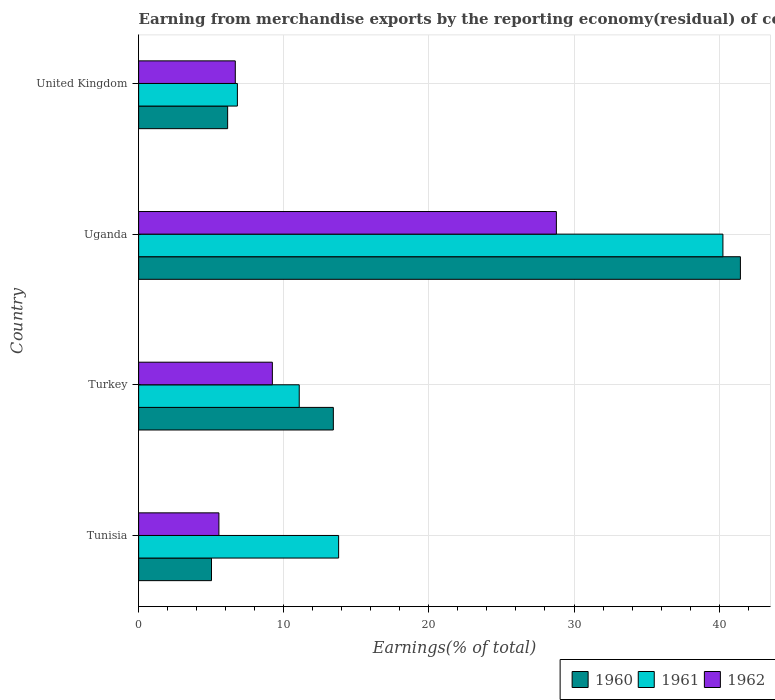How many groups of bars are there?
Your response must be concise. 4. What is the label of the 1st group of bars from the top?
Give a very brief answer. United Kingdom. In how many cases, is the number of bars for a given country not equal to the number of legend labels?
Provide a succinct answer. 0. What is the percentage of amount earned from merchandise exports in 1960 in Turkey?
Provide a succinct answer. 13.42. Across all countries, what is the maximum percentage of amount earned from merchandise exports in 1960?
Your response must be concise. 41.47. Across all countries, what is the minimum percentage of amount earned from merchandise exports in 1962?
Provide a succinct answer. 5.53. In which country was the percentage of amount earned from merchandise exports in 1960 maximum?
Your answer should be very brief. Uganda. In which country was the percentage of amount earned from merchandise exports in 1960 minimum?
Your answer should be compact. Tunisia. What is the total percentage of amount earned from merchandise exports in 1960 in the graph?
Ensure brevity in your answer.  66.04. What is the difference between the percentage of amount earned from merchandise exports in 1960 in Uganda and that in United Kingdom?
Offer a very short reply. 35.33. What is the difference between the percentage of amount earned from merchandise exports in 1961 in Uganda and the percentage of amount earned from merchandise exports in 1960 in United Kingdom?
Provide a succinct answer. 34.13. What is the average percentage of amount earned from merchandise exports in 1960 per country?
Keep it short and to the point. 16.51. What is the difference between the percentage of amount earned from merchandise exports in 1960 and percentage of amount earned from merchandise exports in 1962 in Turkey?
Offer a terse response. 4.2. In how many countries, is the percentage of amount earned from merchandise exports in 1961 greater than 6 %?
Your answer should be very brief. 4. What is the ratio of the percentage of amount earned from merchandise exports in 1961 in Tunisia to that in Uganda?
Your response must be concise. 0.34. What is the difference between the highest and the second highest percentage of amount earned from merchandise exports in 1961?
Offer a terse response. 26.48. What is the difference between the highest and the lowest percentage of amount earned from merchandise exports in 1962?
Keep it short and to the point. 23.25. In how many countries, is the percentage of amount earned from merchandise exports in 1962 greater than the average percentage of amount earned from merchandise exports in 1962 taken over all countries?
Provide a short and direct response. 1. What does the 3rd bar from the top in Turkey represents?
Offer a terse response. 1960. Is it the case that in every country, the sum of the percentage of amount earned from merchandise exports in 1962 and percentage of amount earned from merchandise exports in 1960 is greater than the percentage of amount earned from merchandise exports in 1961?
Your response must be concise. No. How many bars are there?
Ensure brevity in your answer.  12. How many countries are there in the graph?
Make the answer very short. 4. What is the difference between two consecutive major ticks on the X-axis?
Offer a very short reply. 10. Does the graph contain grids?
Provide a succinct answer. Yes. How are the legend labels stacked?
Offer a very short reply. Horizontal. What is the title of the graph?
Provide a short and direct response. Earning from merchandise exports by the reporting economy(residual) of countries. Does "1967" appear as one of the legend labels in the graph?
Provide a succinct answer. No. What is the label or title of the X-axis?
Your answer should be compact. Earnings(% of total). What is the Earnings(% of total) in 1960 in Tunisia?
Your response must be concise. 5.02. What is the Earnings(% of total) of 1961 in Tunisia?
Provide a short and direct response. 13.78. What is the Earnings(% of total) in 1962 in Tunisia?
Offer a very short reply. 5.53. What is the Earnings(% of total) in 1960 in Turkey?
Keep it short and to the point. 13.42. What is the Earnings(% of total) of 1961 in Turkey?
Provide a succinct answer. 11.07. What is the Earnings(% of total) of 1962 in Turkey?
Keep it short and to the point. 9.22. What is the Earnings(% of total) in 1960 in Uganda?
Make the answer very short. 41.47. What is the Earnings(% of total) of 1961 in Uganda?
Provide a short and direct response. 40.26. What is the Earnings(% of total) of 1962 in Uganda?
Your response must be concise. 28.79. What is the Earnings(% of total) in 1960 in United Kingdom?
Give a very brief answer. 6.13. What is the Earnings(% of total) in 1961 in United Kingdom?
Your answer should be very brief. 6.81. What is the Earnings(% of total) of 1962 in United Kingdom?
Provide a succinct answer. 6.66. Across all countries, what is the maximum Earnings(% of total) of 1960?
Your answer should be compact. 41.47. Across all countries, what is the maximum Earnings(% of total) in 1961?
Give a very brief answer. 40.26. Across all countries, what is the maximum Earnings(% of total) in 1962?
Provide a short and direct response. 28.79. Across all countries, what is the minimum Earnings(% of total) in 1960?
Keep it short and to the point. 5.02. Across all countries, what is the minimum Earnings(% of total) in 1961?
Make the answer very short. 6.81. Across all countries, what is the minimum Earnings(% of total) of 1962?
Your answer should be compact. 5.53. What is the total Earnings(% of total) of 1960 in the graph?
Offer a very short reply. 66.04. What is the total Earnings(% of total) of 1961 in the graph?
Make the answer very short. 71.91. What is the total Earnings(% of total) of 1962 in the graph?
Your answer should be very brief. 50.19. What is the difference between the Earnings(% of total) of 1960 in Tunisia and that in Turkey?
Your response must be concise. -8.4. What is the difference between the Earnings(% of total) in 1961 in Tunisia and that in Turkey?
Keep it short and to the point. 2.71. What is the difference between the Earnings(% of total) in 1962 in Tunisia and that in Turkey?
Your response must be concise. -3.68. What is the difference between the Earnings(% of total) in 1960 in Tunisia and that in Uganda?
Offer a terse response. -36.44. What is the difference between the Earnings(% of total) in 1961 in Tunisia and that in Uganda?
Ensure brevity in your answer.  -26.48. What is the difference between the Earnings(% of total) in 1962 in Tunisia and that in Uganda?
Ensure brevity in your answer.  -23.25. What is the difference between the Earnings(% of total) in 1960 in Tunisia and that in United Kingdom?
Offer a terse response. -1.11. What is the difference between the Earnings(% of total) of 1961 in Tunisia and that in United Kingdom?
Provide a succinct answer. 6.98. What is the difference between the Earnings(% of total) of 1962 in Tunisia and that in United Kingdom?
Offer a terse response. -1.13. What is the difference between the Earnings(% of total) in 1960 in Turkey and that in Uganda?
Provide a succinct answer. -28.05. What is the difference between the Earnings(% of total) of 1961 in Turkey and that in Uganda?
Make the answer very short. -29.19. What is the difference between the Earnings(% of total) in 1962 in Turkey and that in Uganda?
Ensure brevity in your answer.  -19.57. What is the difference between the Earnings(% of total) in 1960 in Turkey and that in United Kingdom?
Ensure brevity in your answer.  7.28. What is the difference between the Earnings(% of total) in 1961 in Turkey and that in United Kingdom?
Provide a short and direct response. 4.26. What is the difference between the Earnings(% of total) in 1962 in Turkey and that in United Kingdom?
Offer a very short reply. 2.55. What is the difference between the Earnings(% of total) in 1960 in Uganda and that in United Kingdom?
Your answer should be compact. 35.33. What is the difference between the Earnings(% of total) of 1961 in Uganda and that in United Kingdom?
Make the answer very short. 33.46. What is the difference between the Earnings(% of total) of 1962 in Uganda and that in United Kingdom?
Give a very brief answer. 22.12. What is the difference between the Earnings(% of total) in 1960 in Tunisia and the Earnings(% of total) in 1961 in Turkey?
Your answer should be compact. -6.05. What is the difference between the Earnings(% of total) of 1960 in Tunisia and the Earnings(% of total) of 1962 in Turkey?
Offer a terse response. -4.19. What is the difference between the Earnings(% of total) of 1961 in Tunisia and the Earnings(% of total) of 1962 in Turkey?
Make the answer very short. 4.57. What is the difference between the Earnings(% of total) in 1960 in Tunisia and the Earnings(% of total) in 1961 in Uganda?
Ensure brevity in your answer.  -35.24. What is the difference between the Earnings(% of total) in 1960 in Tunisia and the Earnings(% of total) in 1962 in Uganda?
Ensure brevity in your answer.  -23.76. What is the difference between the Earnings(% of total) in 1961 in Tunisia and the Earnings(% of total) in 1962 in Uganda?
Offer a terse response. -15. What is the difference between the Earnings(% of total) in 1960 in Tunisia and the Earnings(% of total) in 1961 in United Kingdom?
Your response must be concise. -1.78. What is the difference between the Earnings(% of total) of 1960 in Tunisia and the Earnings(% of total) of 1962 in United Kingdom?
Provide a succinct answer. -1.64. What is the difference between the Earnings(% of total) of 1961 in Tunisia and the Earnings(% of total) of 1962 in United Kingdom?
Provide a short and direct response. 7.12. What is the difference between the Earnings(% of total) of 1960 in Turkey and the Earnings(% of total) of 1961 in Uganda?
Ensure brevity in your answer.  -26.84. What is the difference between the Earnings(% of total) in 1960 in Turkey and the Earnings(% of total) in 1962 in Uganda?
Ensure brevity in your answer.  -15.37. What is the difference between the Earnings(% of total) in 1961 in Turkey and the Earnings(% of total) in 1962 in Uganda?
Make the answer very short. -17.72. What is the difference between the Earnings(% of total) in 1960 in Turkey and the Earnings(% of total) in 1961 in United Kingdom?
Keep it short and to the point. 6.61. What is the difference between the Earnings(% of total) of 1960 in Turkey and the Earnings(% of total) of 1962 in United Kingdom?
Offer a very short reply. 6.76. What is the difference between the Earnings(% of total) of 1961 in Turkey and the Earnings(% of total) of 1962 in United Kingdom?
Give a very brief answer. 4.41. What is the difference between the Earnings(% of total) in 1960 in Uganda and the Earnings(% of total) in 1961 in United Kingdom?
Your answer should be very brief. 34.66. What is the difference between the Earnings(% of total) of 1960 in Uganda and the Earnings(% of total) of 1962 in United Kingdom?
Your response must be concise. 34.8. What is the difference between the Earnings(% of total) in 1961 in Uganda and the Earnings(% of total) in 1962 in United Kingdom?
Offer a terse response. 33.6. What is the average Earnings(% of total) in 1960 per country?
Your answer should be very brief. 16.51. What is the average Earnings(% of total) of 1961 per country?
Your answer should be compact. 17.98. What is the average Earnings(% of total) in 1962 per country?
Provide a short and direct response. 12.55. What is the difference between the Earnings(% of total) in 1960 and Earnings(% of total) in 1961 in Tunisia?
Provide a short and direct response. -8.76. What is the difference between the Earnings(% of total) in 1960 and Earnings(% of total) in 1962 in Tunisia?
Offer a very short reply. -0.51. What is the difference between the Earnings(% of total) in 1961 and Earnings(% of total) in 1962 in Tunisia?
Provide a short and direct response. 8.25. What is the difference between the Earnings(% of total) in 1960 and Earnings(% of total) in 1961 in Turkey?
Provide a succinct answer. 2.35. What is the difference between the Earnings(% of total) in 1960 and Earnings(% of total) in 1962 in Turkey?
Provide a short and direct response. 4.2. What is the difference between the Earnings(% of total) of 1961 and Earnings(% of total) of 1962 in Turkey?
Offer a very short reply. 1.85. What is the difference between the Earnings(% of total) of 1960 and Earnings(% of total) of 1961 in Uganda?
Your response must be concise. 1.2. What is the difference between the Earnings(% of total) of 1960 and Earnings(% of total) of 1962 in Uganda?
Your answer should be compact. 12.68. What is the difference between the Earnings(% of total) in 1961 and Earnings(% of total) in 1962 in Uganda?
Provide a succinct answer. 11.48. What is the difference between the Earnings(% of total) in 1960 and Earnings(% of total) in 1961 in United Kingdom?
Make the answer very short. -0.67. What is the difference between the Earnings(% of total) of 1960 and Earnings(% of total) of 1962 in United Kingdom?
Make the answer very short. -0.53. What is the difference between the Earnings(% of total) of 1961 and Earnings(% of total) of 1962 in United Kingdom?
Provide a short and direct response. 0.14. What is the ratio of the Earnings(% of total) of 1960 in Tunisia to that in Turkey?
Offer a very short reply. 0.37. What is the ratio of the Earnings(% of total) of 1961 in Tunisia to that in Turkey?
Ensure brevity in your answer.  1.25. What is the ratio of the Earnings(% of total) of 1962 in Tunisia to that in Turkey?
Make the answer very short. 0.6. What is the ratio of the Earnings(% of total) of 1960 in Tunisia to that in Uganda?
Your response must be concise. 0.12. What is the ratio of the Earnings(% of total) in 1961 in Tunisia to that in Uganda?
Your answer should be compact. 0.34. What is the ratio of the Earnings(% of total) in 1962 in Tunisia to that in Uganda?
Keep it short and to the point. 0.19. What is the ratio of the Earnings(% of total) of 1960 in Tunisia to that in United Kingdom?
Give a very brief answer. 0.82. What is the ratio of the Earnings(% of total) in 1961 in Tunisia to that in United Kingdom?
Provide a succinct answer. 2.02. What is the ratio of the Earnings(% of total) of 1962 in Tunisia to that in United Kingdom?
Keep it short and to the point. 0.83. What is the ratio of the Earnings(% of total) in 1960 in Turkey to that in Uganda?
Offer a very short reply. 0.32. What is the ratio of the Earnings(% of total) of 1961 in Turkey to that in Uganda?
Provide a succinct answer. 0.27. What is the ratio of the Earnings(% of total) in 1962 in Turkey to that in Uganda?
Offer a very short reply. 0.32. What is the ratio of the Earnings(% of total) in 1960 in Turkey to that in United Kingdom?
Offer a very short reply. 2.19. What is the ratio of the Earnings(% of total) in 1961 in Turkey to that in United Kingdom?
Keep it short and to the point. 1.63. What is the ratio of the Earnings(% of total) of 1962 in Turkey to that in United Kingdom?
Provide a succinct answer. 1.38. What is the ratio of the Earnings(% of total) in 1960 in Uganda to that in United Kingdom?
Provide a succinct answer. 6.76. What is the ratio of the Earnings(% of total) of 1961 in Uganda to that in United Kingdom?
Offer a very short reply. 5.92. What is the ratio of the Earnings(% of total) in 1962 in Uganda to that in United Kingdom?
Make the answer very short. 4.32. What is the difference between the highest and the second highest Earnings(% of total) of 1960?
Offer a very short reply. 28.05. What is the difference between the highest and the second highest Earnings(% of total) of 1961?
Provide a succinct answer. 26.48. What is the difference between the highest and the second highest Earnings(% of total) in 1962?
Ensure brevity in your answer.  19.57. What is the difference between the highest and the lowest Earnings(% of total) in 1960?
Offer a very short reply. 36.44. What is the difference between the highest and the lowest Earnings(% of total) in 1961?
Provide a short and direct response. 33.46. What is the difference between the highest and the lowest Earnings(% of total) of 1962?
Ensure brevity in your answer.  23.25. 